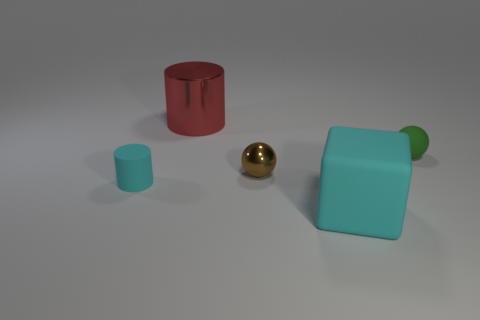There is a cyan object to the right of the small thing left of the brown shiny object; are there any big cyan things that are left of it?
Keep it short and to the point. No. The shiny object that is behind the small object that is right of the object in front of the tiny matte cylinder is what color?
Provide a short and direct response. Red. There is a small cyan thing that is the same shape as the large metallic thing; what material is it?
Give a very brief answer. Rubber. How big is the cyan matte object right of the tiny rubber thing in front of the brown ball?
Keep it short and to the point. Large. What material is the cyan thing that is right of the large red cylinder?
Provide a succinct answer. Rubber. What is the size of the cube that is made of the same material as the green thing?
Offer a terse response. Large. What number of other rubber things are the same shape as the red object?
Your answer should be compact. 1. There is a large red metallic thing; does it have the same shape as the small object that is to the right of the big cyan thing?
Provide a succinct answer. No. What is the shape of the rubber thing that is the same color as the matte cylinder?
Your response must be concise. Cube. Is there another cylinder made of the same material as the tiny cyan cylinder?
Provide a succinct answer. No. 